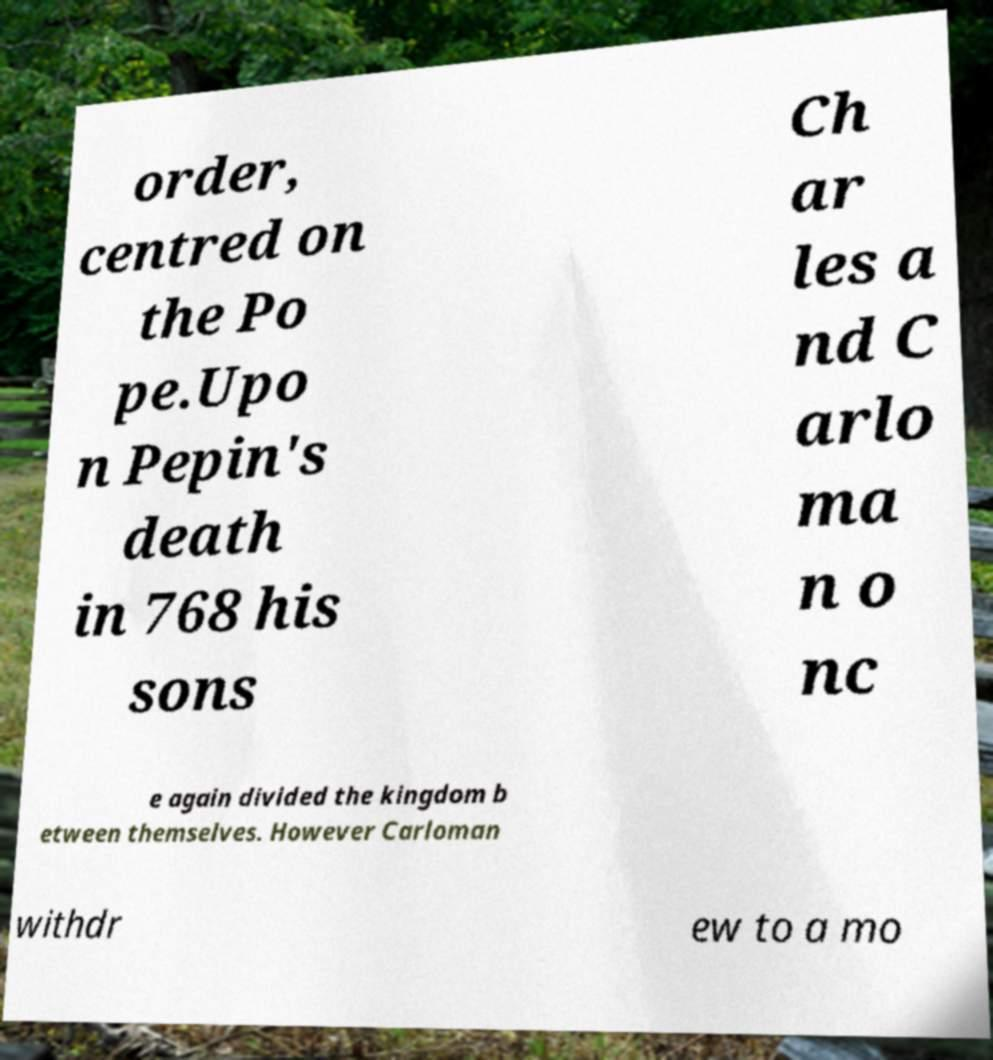I need the written content from this picture converted into text. Can you do that? order, centred on the Po pe.Upo n Pepin's death in 768 his sons Ch ar les a nd C arlo ma n o nc e again divided the kingdom b etween themselves. However Carloman withdr ew to a mo 